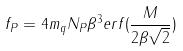Convert formula to latex. <formula><loc_0><loc_0><loc_500><loc_500>f _ { P } = 4 m _ { q } N _ { P } \beta ^ { 3 } e r f ( \frac { M } { 2 \beta \sqrt { 2 } } )</formula> 